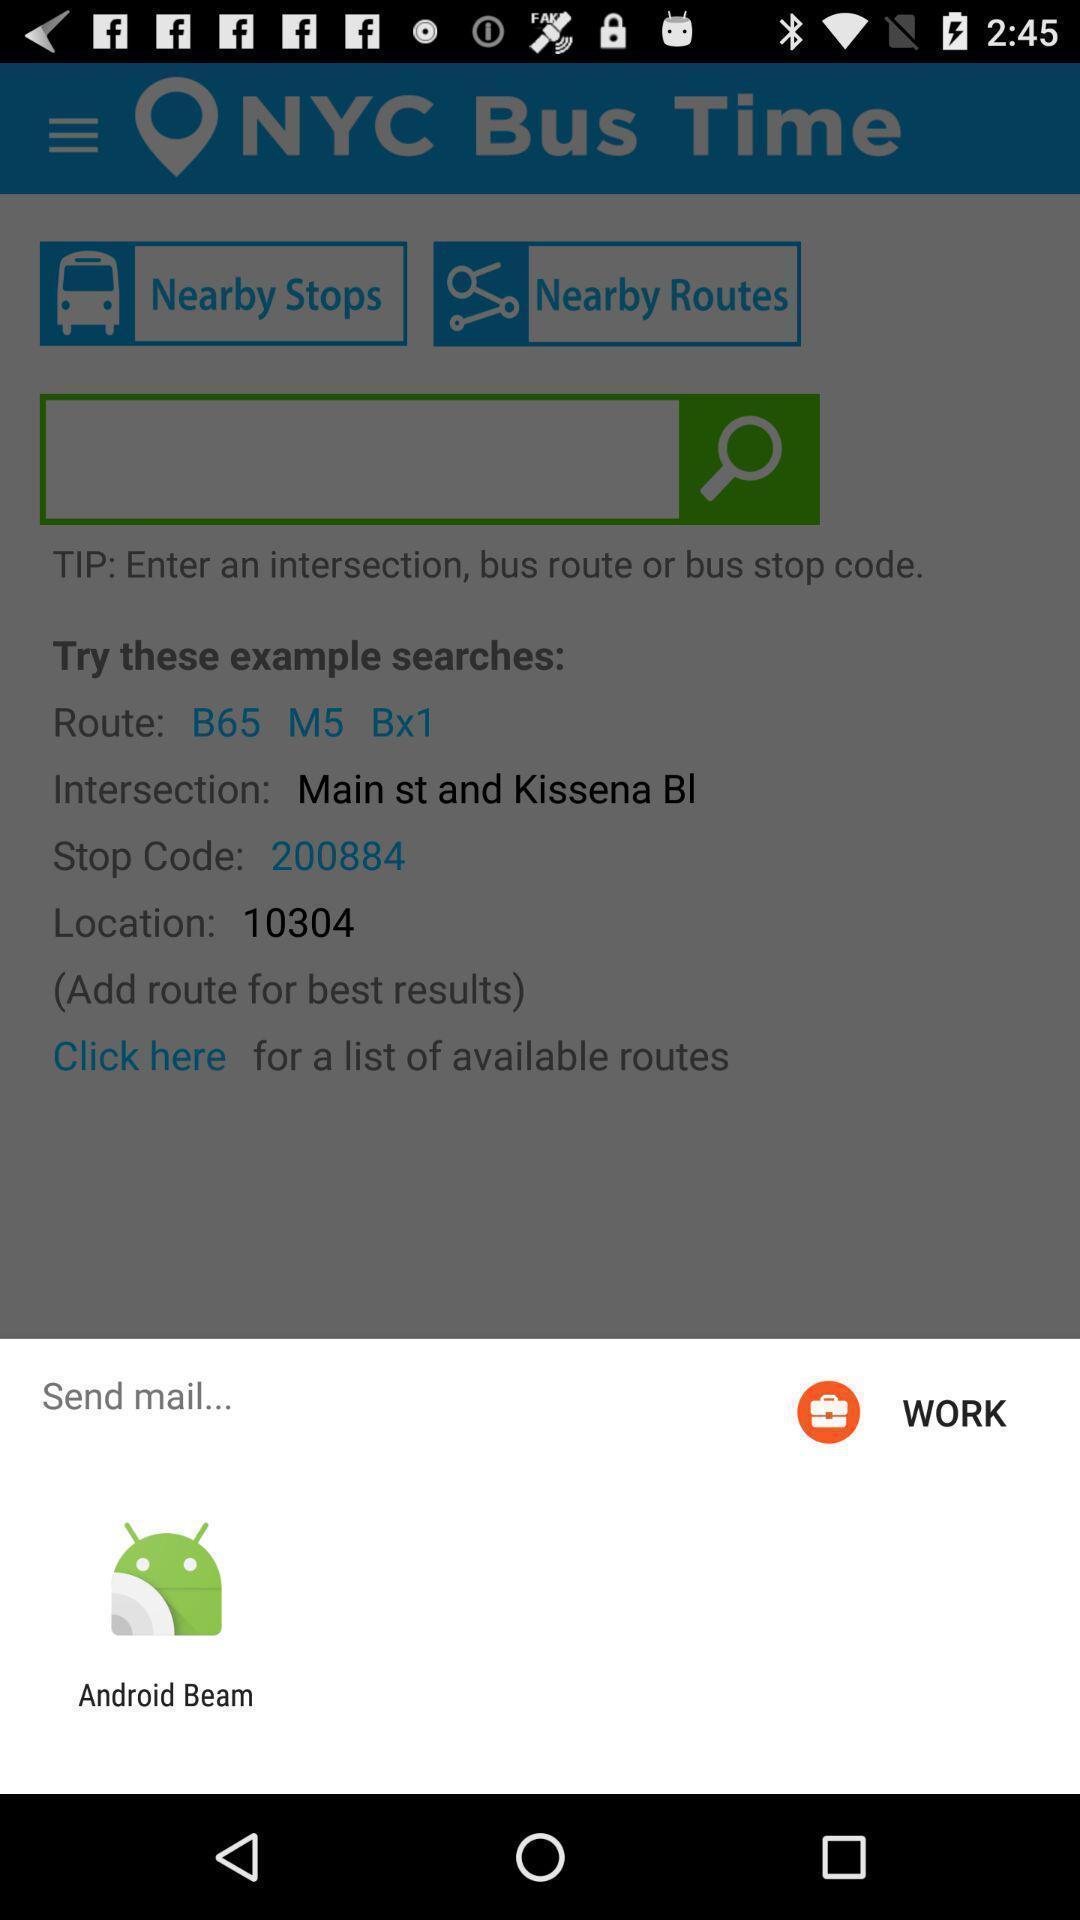Tell me about the visual elements in this screen capture. Pop-up widget is showing a data transferring app. 